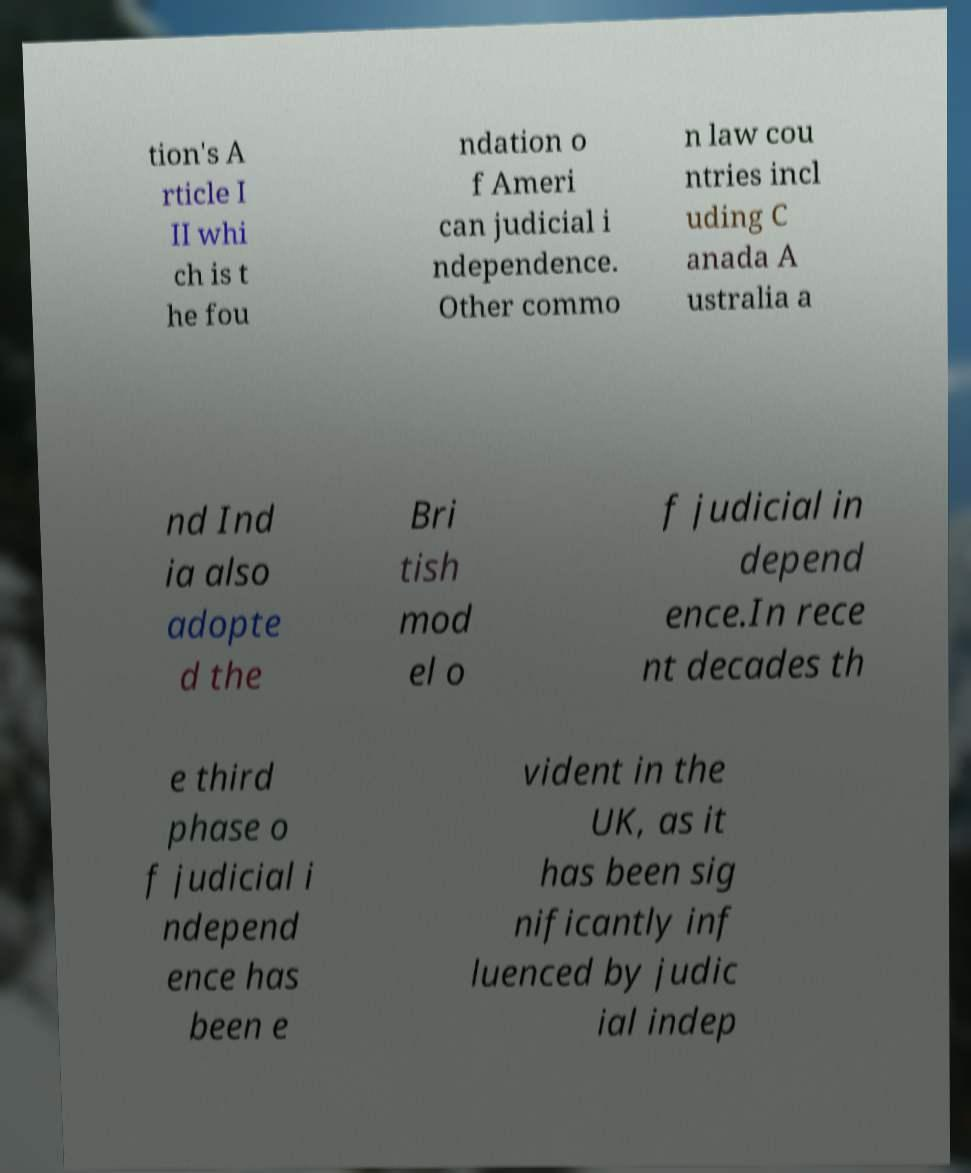Could you extract and type out the text from this image? tion's A rticle I II whi ch is t he fou ndation o f Ameri can judicial i ndependence. Other commo n law cou ntries incl uding C anada A ustralia a nd Ind ia also adopte d the Bri tish mod el o f judicial in depend ence.In rece nt decades th e third phase o f judicial i ndepend ence has been e vident in the UK, as it has been sig nificantly inf luenced by judic ial indep 